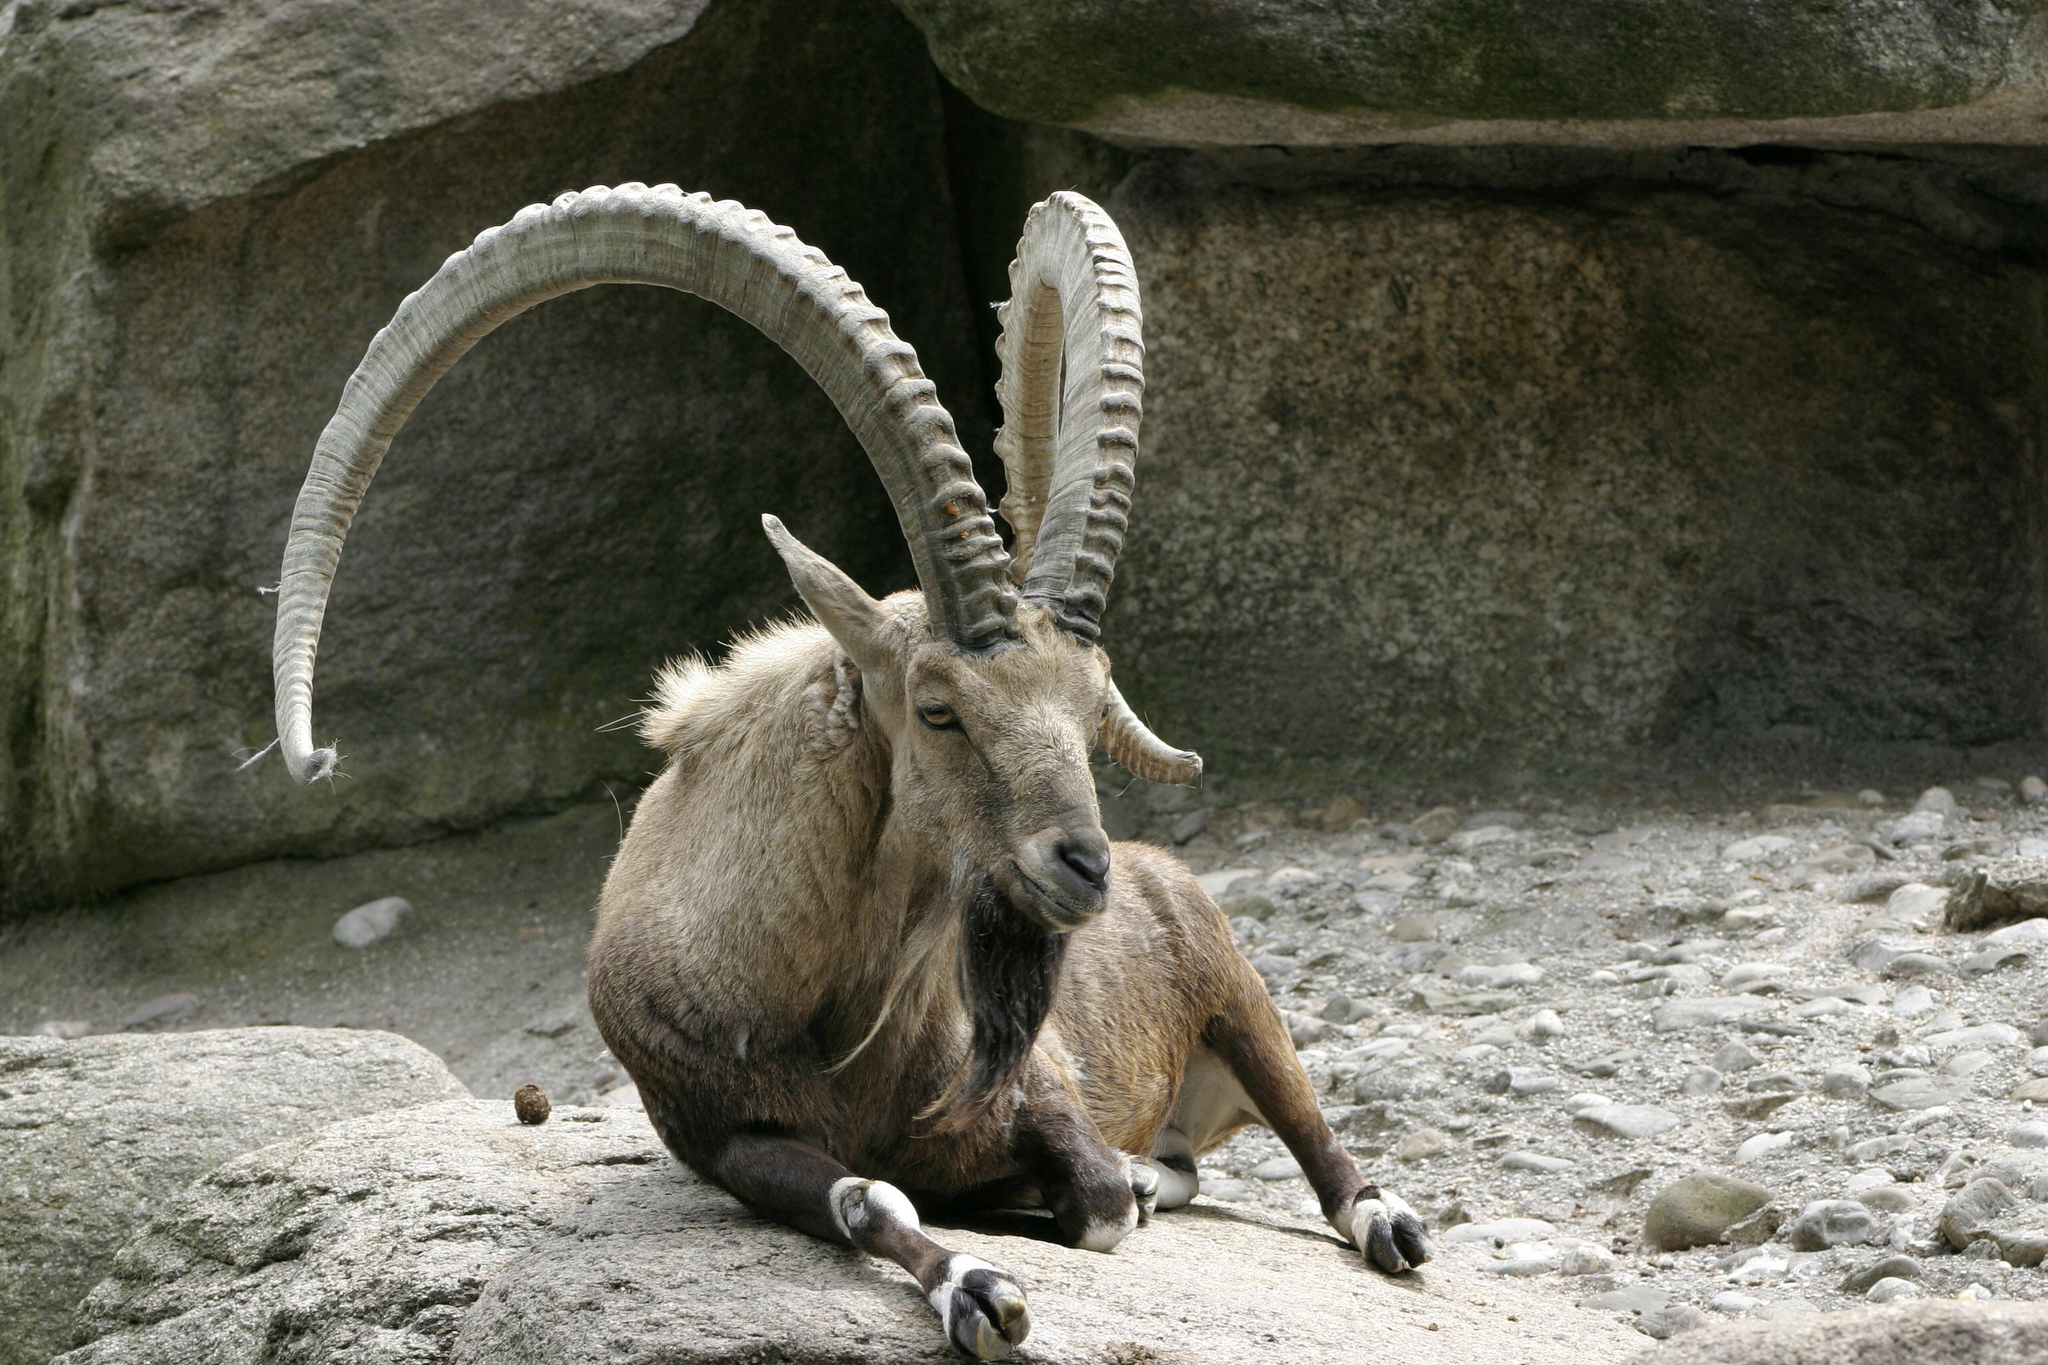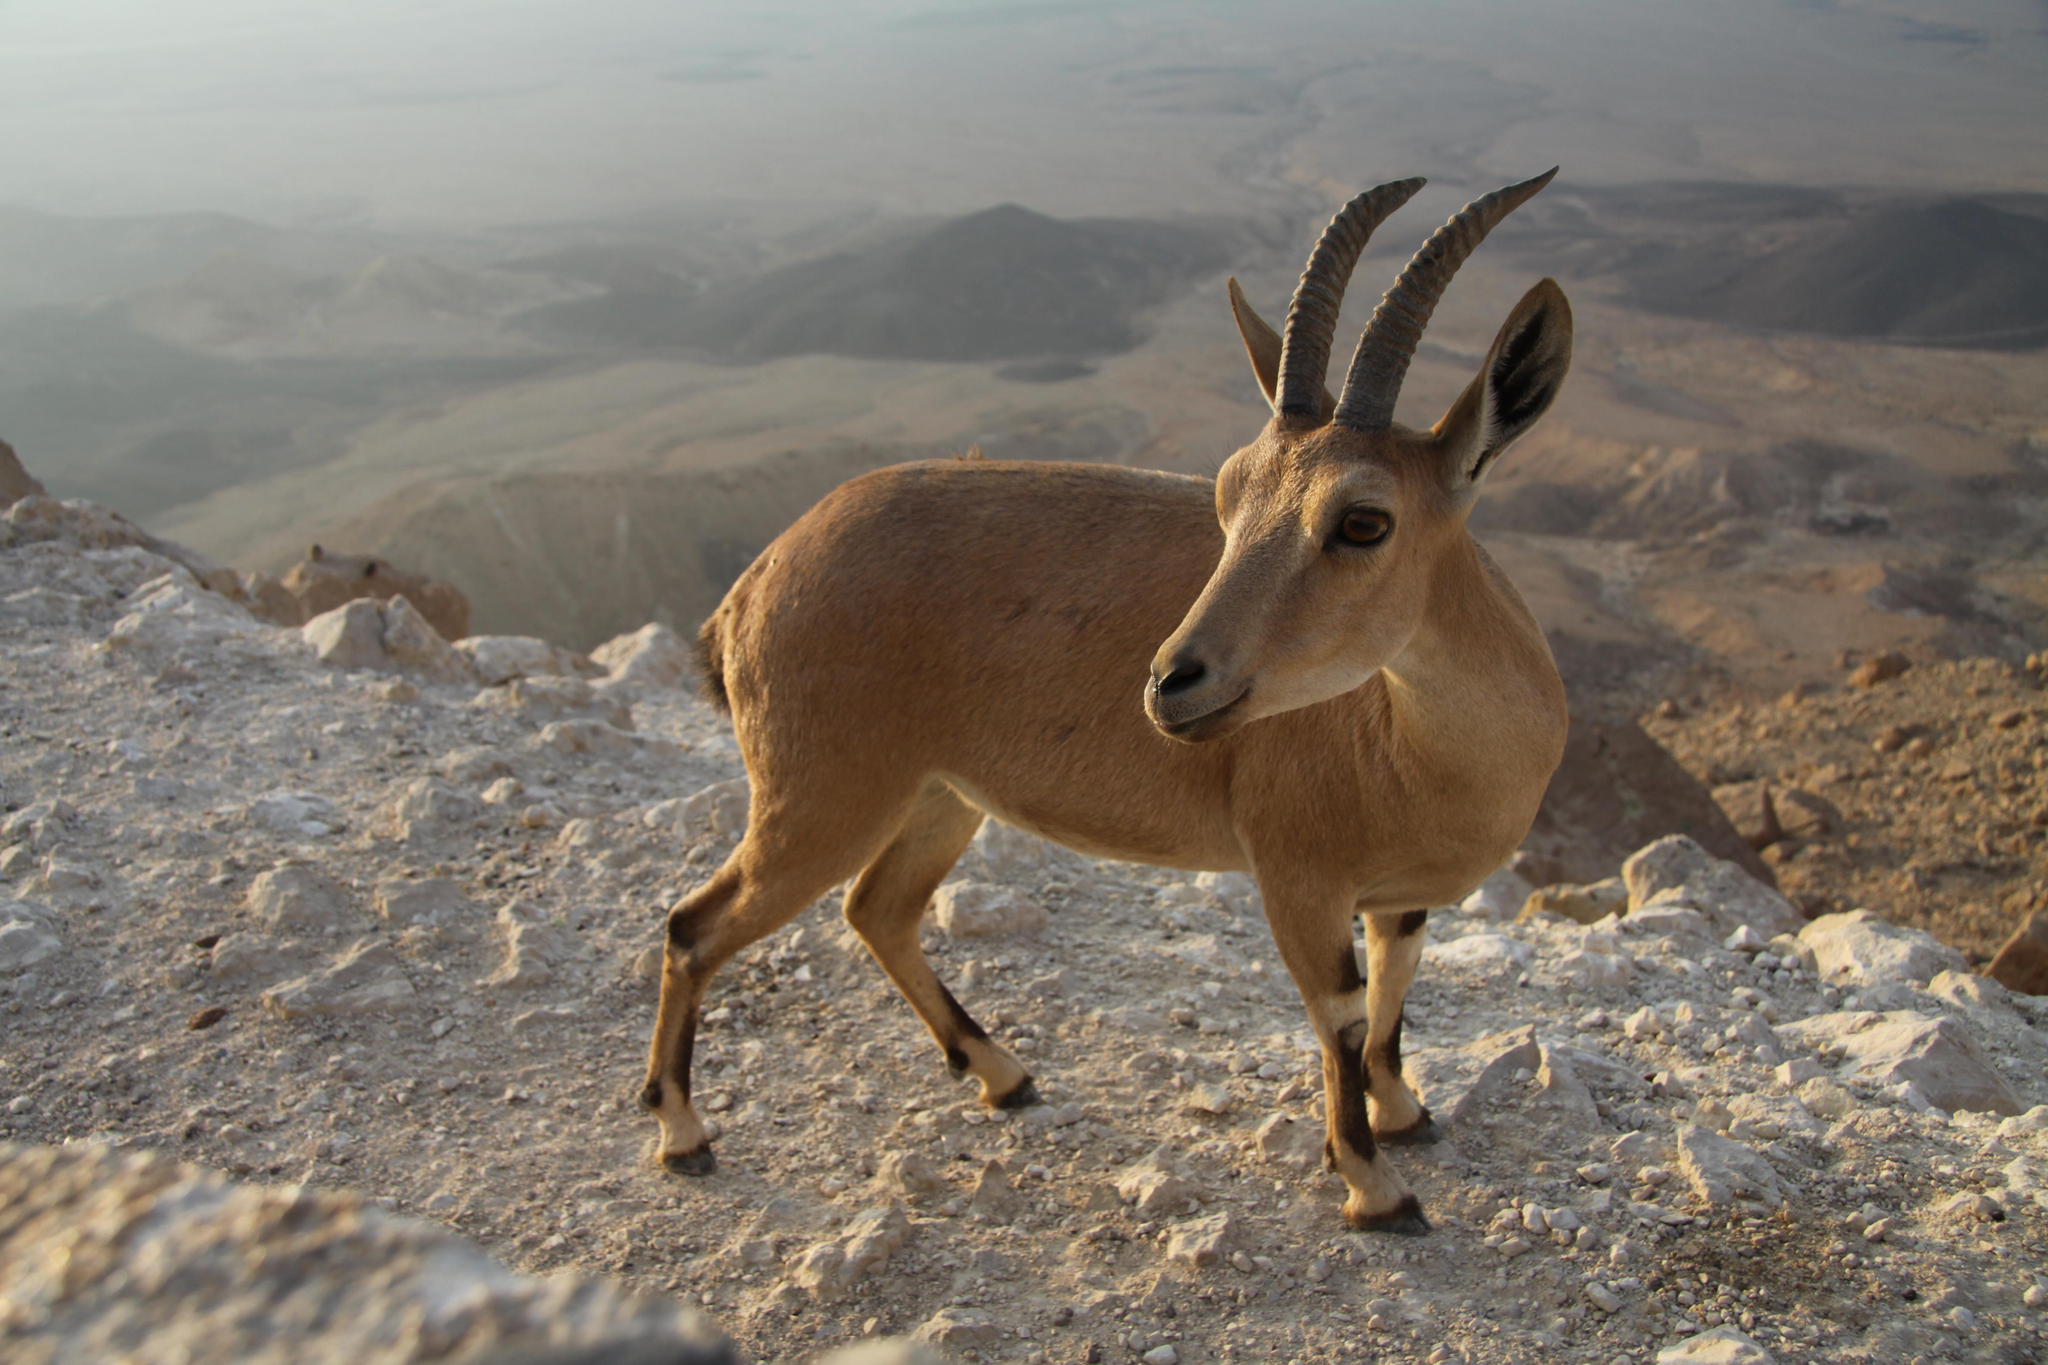The first image is the image on the left, the second image is the image on the right. For the images shown, is this caption "Each image contains just one horned animal, and one image shows an animal reclining on a rock, with large boulders behind it." true? Answer yes or no. Yes. 